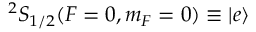Convert formula to latex. <formula><loc_0><loc_0><loc_500><loc_500>{ } ^ { 2 } S _ { 1 / 2 } ( F = 0 , m _ { F } = 0 ) \equiv \left | e \right \rangle</formula> 